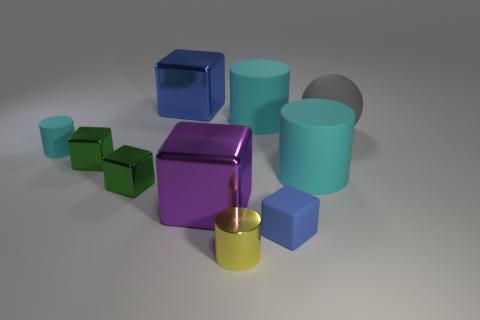Can you describe the lighting situation in the photo? The lighting in the image seems to be coming from above, slightly toward the front, casting soft shadows primarily behind and to the right of the objects. It's likely a single light source, considering the uniformity of the shadows. 